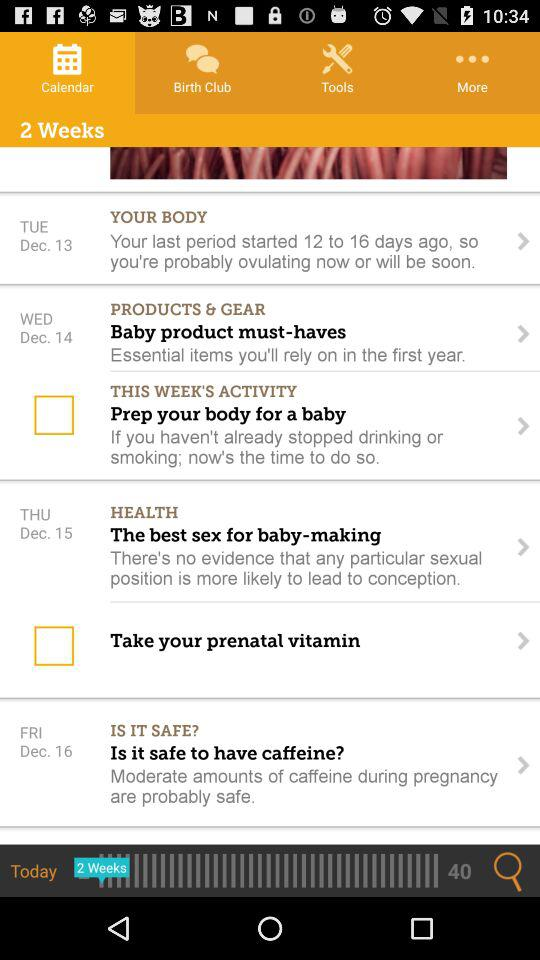Which date is shown for "IS IT SAFE?"? The date is Friday, December 16. 